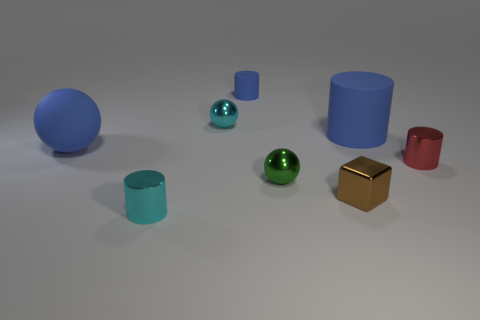The rubber object that is the same size as the cyan sphere is what shape?
Offer a very short reply. Cylinder. Are there any yellow things of the same shape as the tiny green metal object?
Provide a succinct answer. No. There is a large blue thing that is behind the large thing that is on the left side of the tiny rubber cylinder; are there any large blue spheres behind it?
Your answer should be very brief. No. Is the number of tiny spheres that are behind the blue sphere greater than the number of big balls that are in front of the cyan metal cylinder?
Your answer should be very brief. Yes. There is a cyan thing that is the same size as the cyan metallic ball; what material is it?
Ensure brevity in your answer.  Metal. How many big things are cyan cylinders or purple cylinders?
Keep it short and to the point. 0. Do the tiny green object and the small red thing have the same shape?
Provide a succinct answer. No. How many cyan things are in front of the green sphere and behind the brown object?
Make the answer very short. 0. Are there any other things of the same color as the small matte cylinder?
Make the answer very short. Yes. What shape is the brown thing that is made of the same material as the small red object?
Offer a terse response. Cube. 